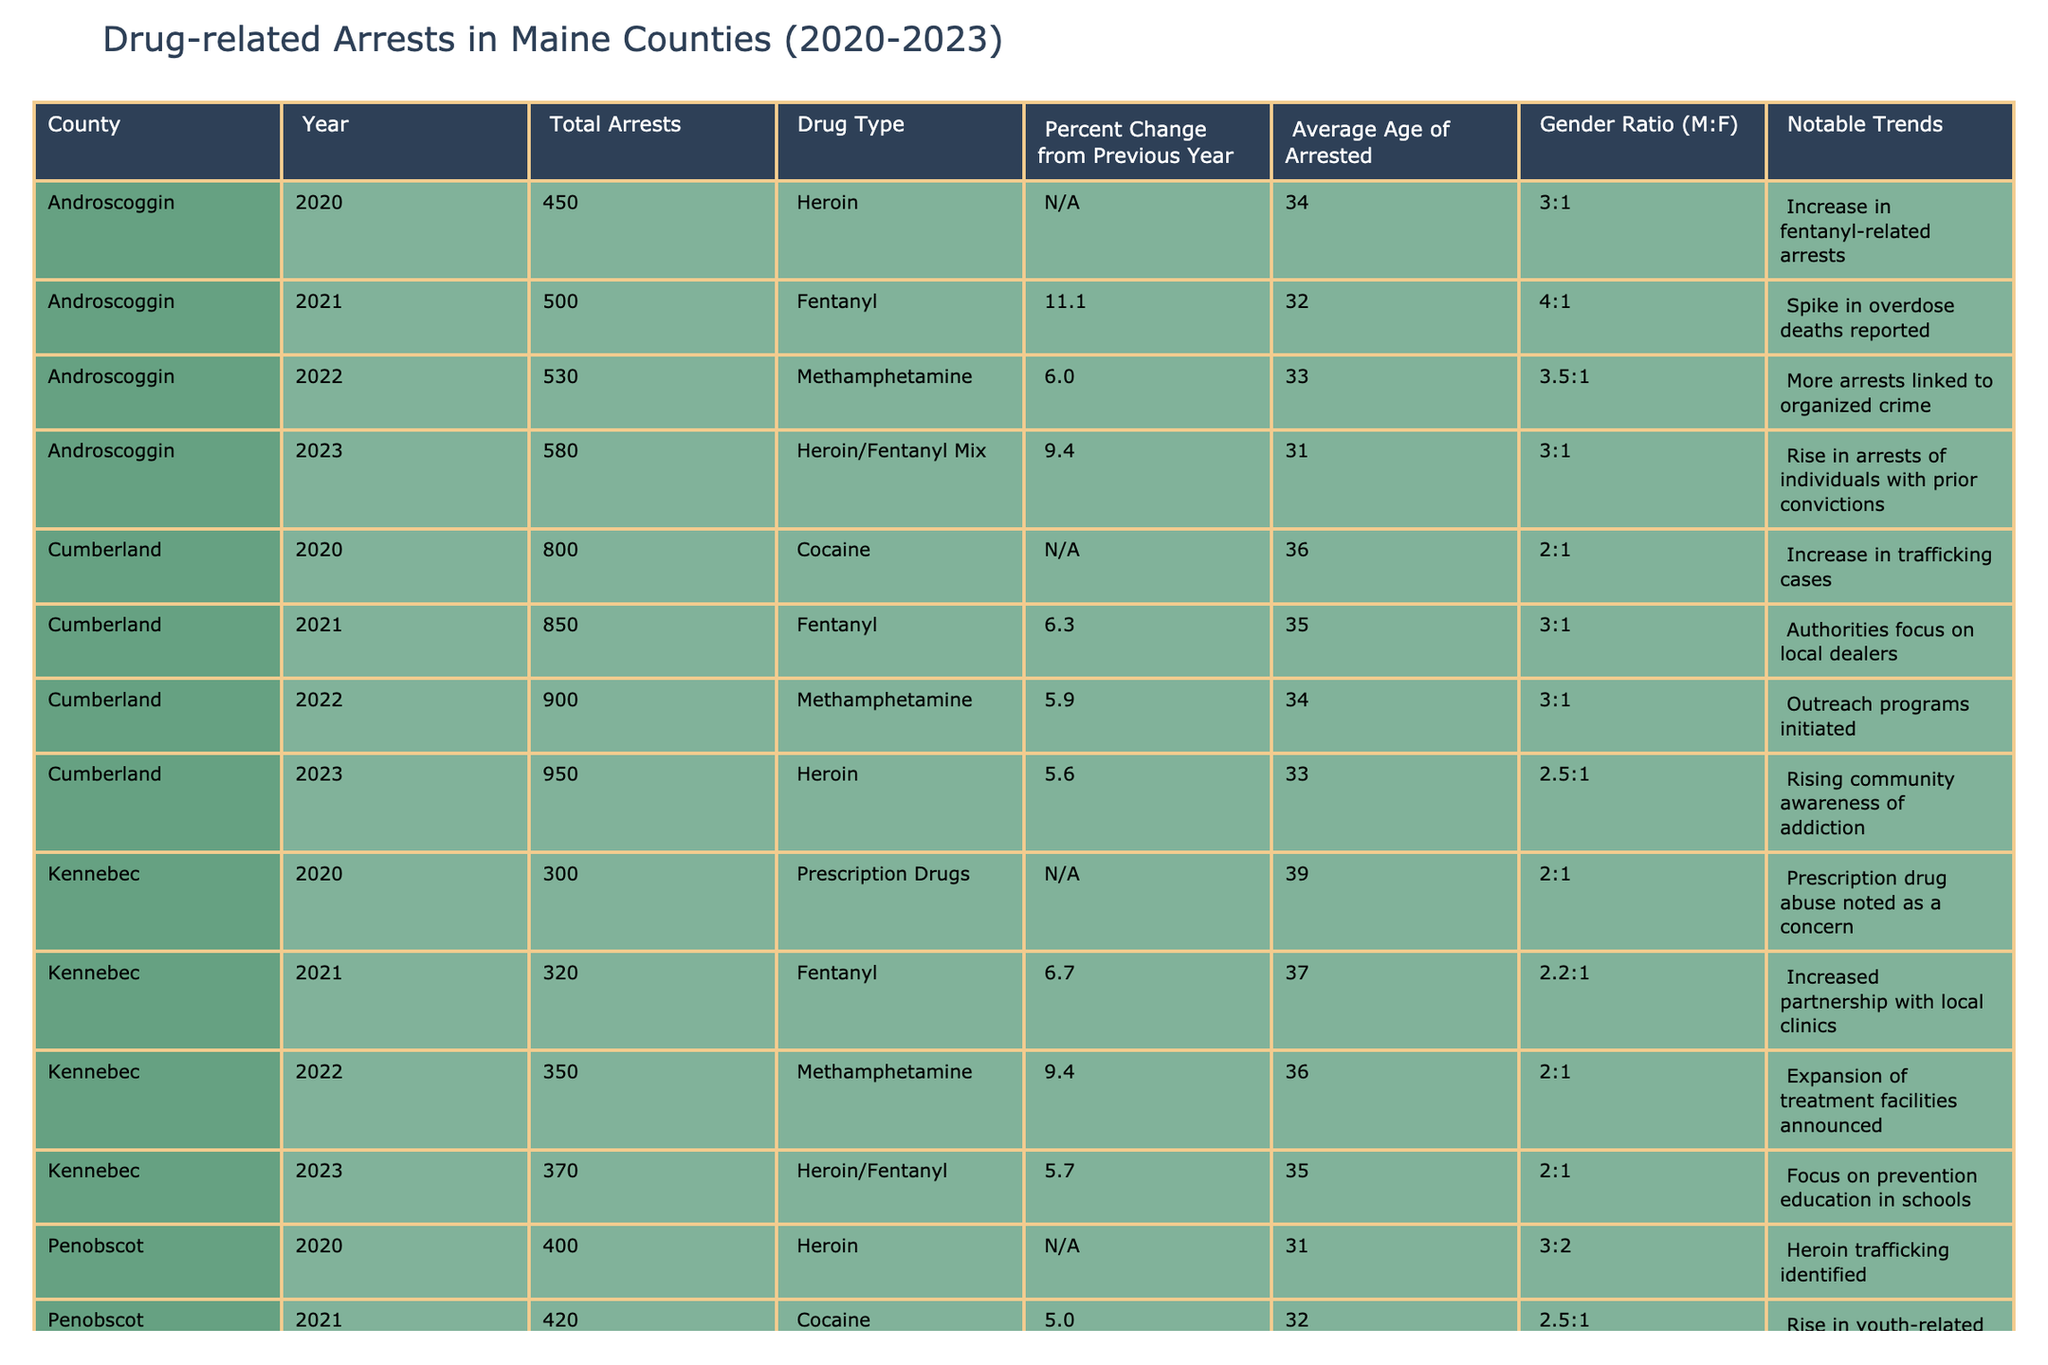What was the total number of drug-related arrests in Cumberland County in 2022? From the table, we can directly find the entry for Cumberland County in 2022, which states that there were 900 total arrests.
Answer: 900 Which county had the highest average age of arrested individuals in 2020? By examining the average age listed for each county in the year 2020, we see that Kennebec County had the highest average age of 39.
Answer: Kennebec What was the percent change in drug-related arrests in Penobscot County from 2022 to 2023? The percent change from Penobscot County in 2022 is 19.0, and in 2023, it is 10.0. To find the percent change, we calculate (10.0 - 19.0) / 19.0 * 100 = -47.37%. Therefore, there's a decrease of 47.37%.
Answer: -47.37% Did York County experience an increase in drug-related arrests from 2021 to 2022? Looking at the total arrests for York County, in 2021 there were 620, and in 2022 there were 700. Since 700 is greater than 620, this indicates an increase.
Answer: Yes What was the overall trend of drug-related arrests in Androscoggin County from 2020 to 2023? Analyzing the trends: In 2020, there were 450 arrests. In 2021, it increased to 500. In 2022, it rose to 530, and finally, in 2023, it reached 580. Therefore, the trend shows a steady increase over the years.
Answer: Steady increase Calculate the average total arrests across all counties in 2023. We assess the total arrests for each county in 2023: Androscoggin (580), Cumberland (950), Kennebec (370), Penobscot (550), and York (750). The sum is 580 + 950 + 370 + 550 + 750 = 3150. To find the average, we divide by 5, giving us 3150 / 5 = 630.
Answer: 630 Which drug type had the least average arrests over the years across all counties? By examining each drug type's total arrests by year, we can observe that prescription drugs recorded the least total arrests within the table during its entries in 2020 to 2023, indicating lower prevalence.
Answer: Prescription Drugs In 2022, which county reported a notable trend in organized crime related to drug arrests? The table clearly states that in Androscoggin County for the year 2022, there is a notable trend linked to organized crime, highlighting the specific connection to arrests that year.
Answer: Androscoggin Was there an increase in fentanyl arrests in Kennebec County from 2021 to 2022? In Kennebec County, the total arrests for fentanyl in 2021 were 320, and in 2022 it increased to 350. Since 350 is greater than 320, there indeed was an increase.
Answer: Yes What trend was observed in Penobscot County regarding youth-related drug incidents? The trend noted in the table suggests that in 2021, Penobscot County reported a rise in youth-related incidents, indicating a concern regarding such demographics tied to drug-related arrests.
Answer: Rise in youth-related incidents 